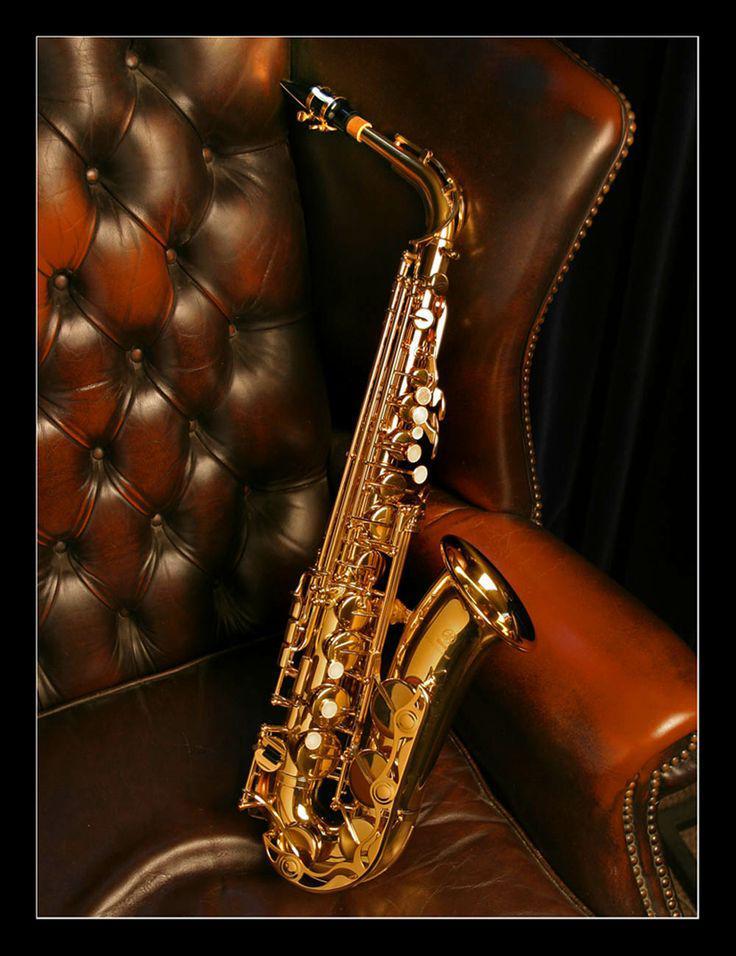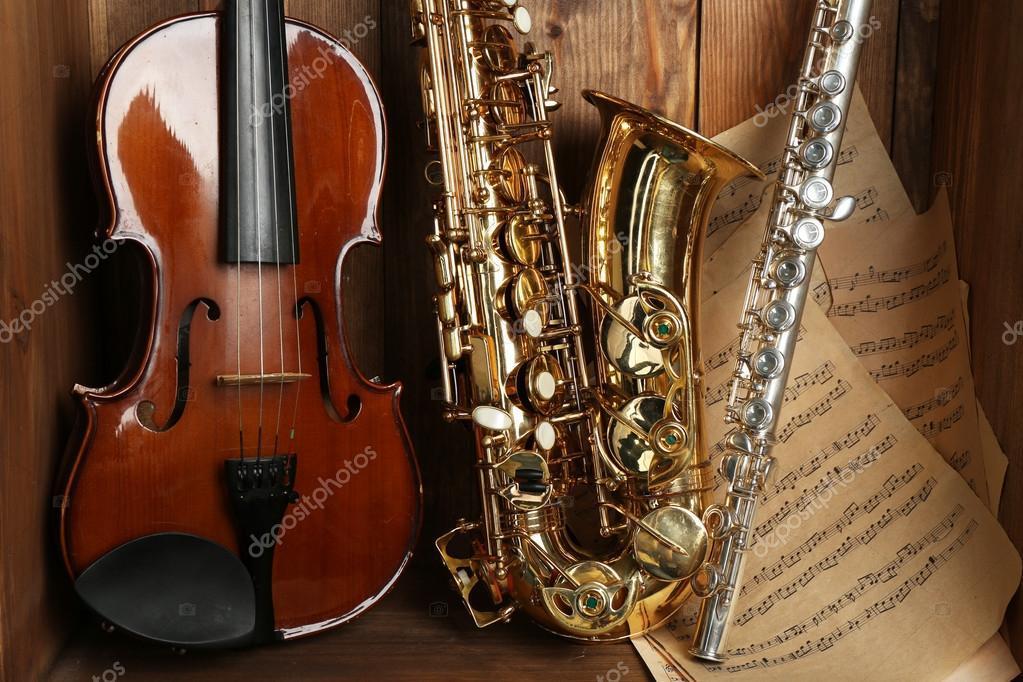The first image is the image on the left, the second image is the image on the right. Given the left and right images, does the statement "A saxophone stands alone in the image on the left." hold true? Answer yes or no. Yes. The first image is the image on the left, the second image is the image on the right. Assess this claim about the two images: "An image shows a guitar, a gold saxophone, and a silver clarinet, all standing upright side-by-side.". Correct or not? Answer yes or no. Yes. 